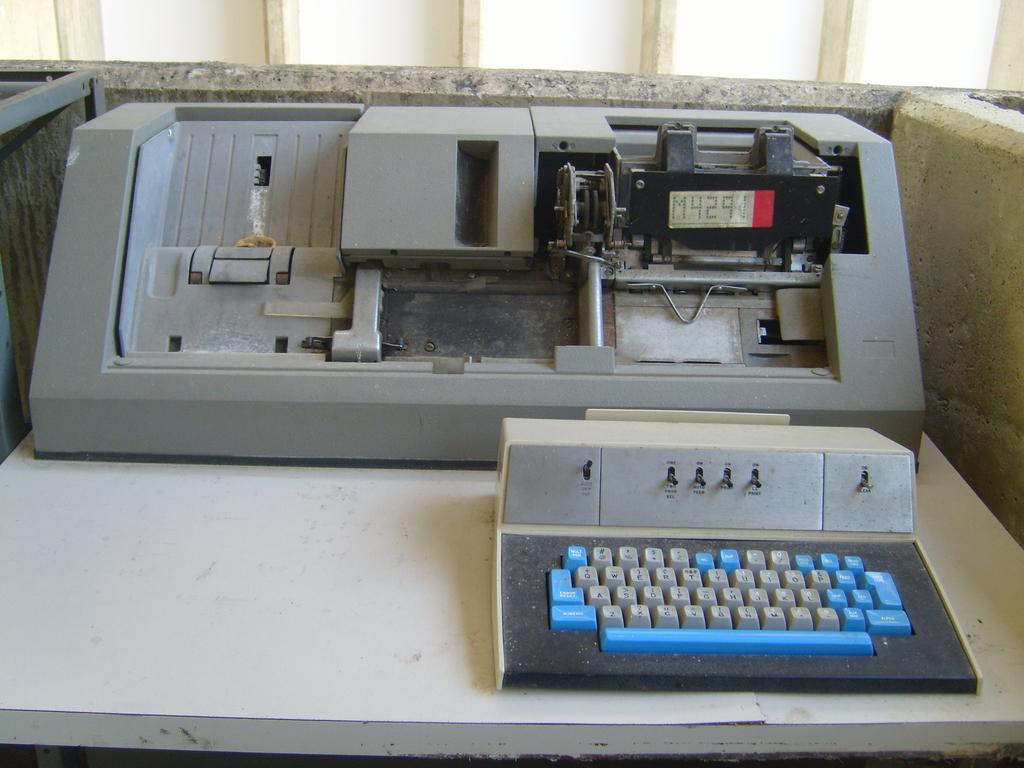What is on the screen?
Your answer should be compact. M4291. 